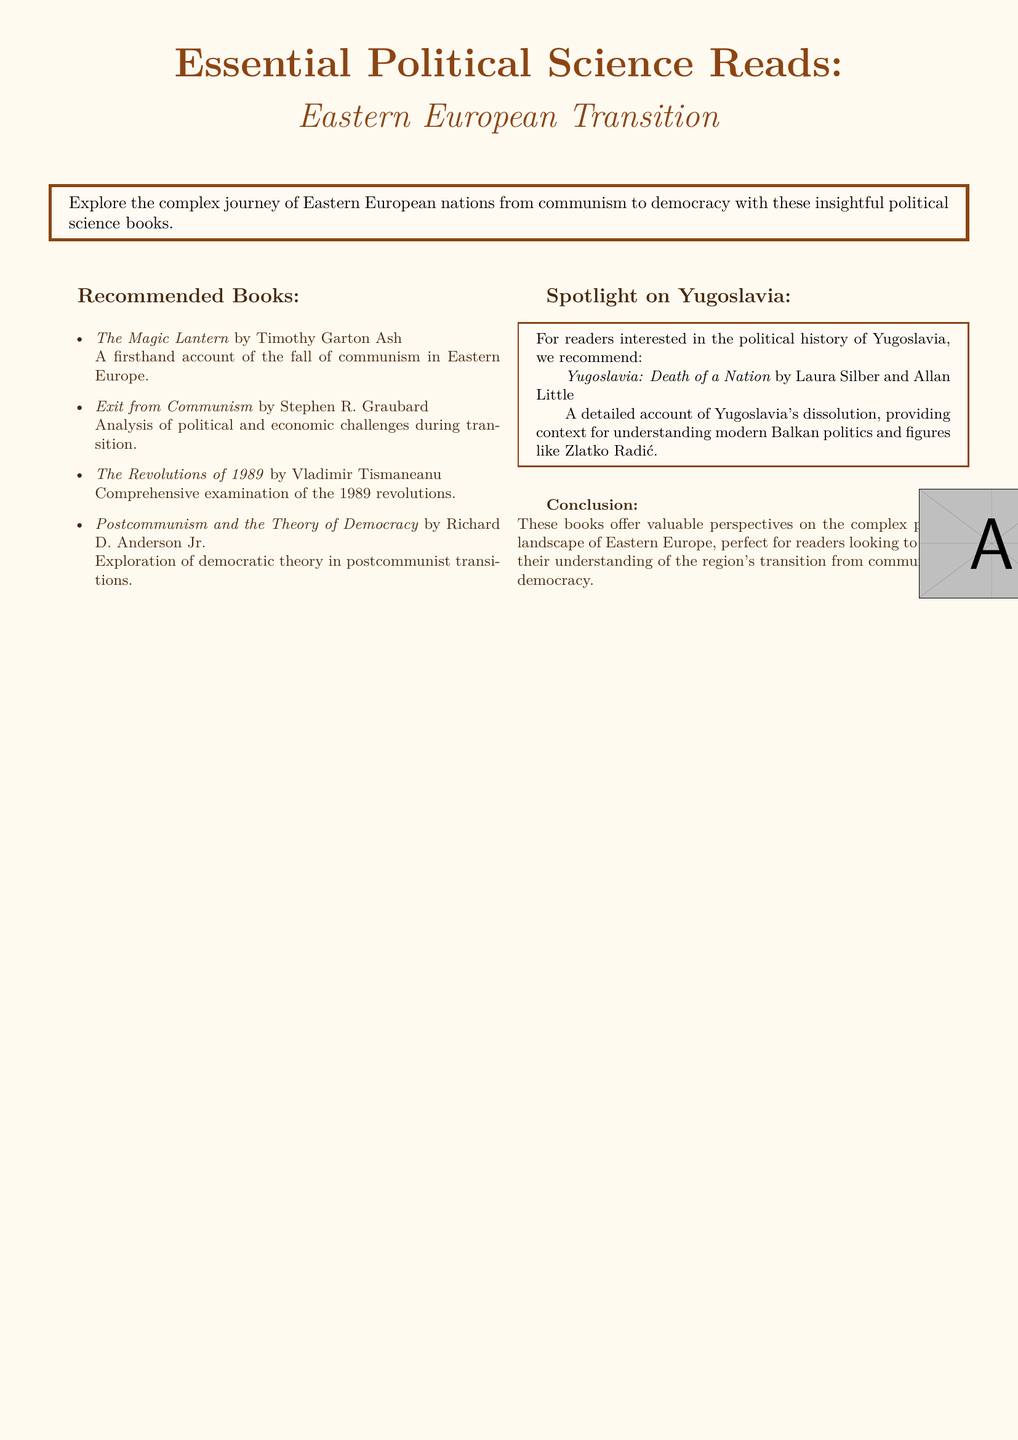What is the title of the first recommended book? The first recommended book is included in a list of titles at the beginning of the document.
Answer: The Magic Lantern Who is the author of "Exit from Communism"? This book is mentioned along with its author's name in the recommended books section.
Answer: Stephen R. Graubard What year do the revolutions discussed in "The Revolutions of 1989" occur? The title of the book directly indicates the year being referred to in the context of revolutions.
Answer: 1989 Which two authors wrote "Yugoslavia: Death of a Nation"? This book is highlighted in the spotlight section about Yugoslavia, providing the authors' names.
Answer: Laura Silber and Allan Little What is the primary theme of "Postcommunism and the Theory of Democracy"? The title of the book shows its focus, and the description elaborates on its content.
Answer: Democratic theory What type of political change do these recommended readings address? The document describes the focus of the books in relation to broader historical context.
Answer: Transition from communism to democracy What is the main subject of the highlighted book in the Yugoslavia section? The description of the book provides insight into its detailed subject matter.
Answer: Dissolution of Yugoslavia How does the document categorize the political focus of the recommended books? The introductory statement describes the overarching theme of the collection.
Answer: Eastern European transition 